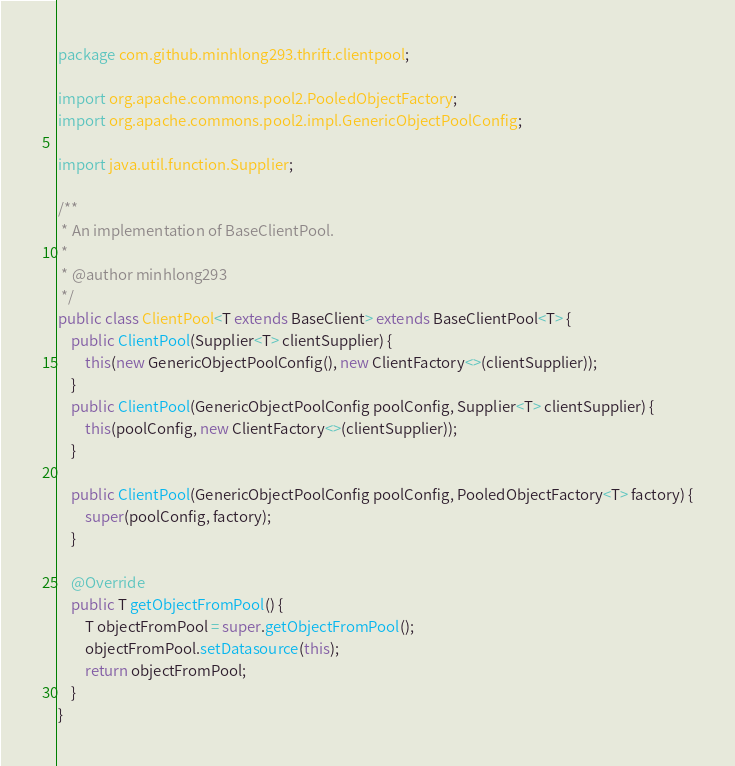<code> <loc_0><loc_0><loc_500><loc_500><_Java_>package com.github.minhlong293.thrift.clientpool;

import org.apache.commons.pool2.PooledObjectFactory;
import org.apache.commons.pool2.impl.GenericObjectPoolConfig;

import java.util.function.Supplier;

/**
 * An implementation of BaseClientPool.
 *
 * @author minhlong293
 */
public class ClientPool<T extends BaseClient> extends BaseClientPool<T> {
    public ClientPool(Supplier<T> clientSupplier) {
        this(new GenericObjectPoolConfig(), new ClientFactory<>(clientSupplier));
    }
    public ClientPool(GenericObjectPoolConfig poolConfig, Supplier<T> clientSupplier) {
        this(poolConfig, new ClientFactory<>(clientSupplier));
    }

    public ClientPool(GenericObjectPoolConfig poolConfig, PooledObjectFactory<T> factory) {
        super(poolConfig, factory);
    }

    @Override
    public T getObjectFromPool() {
        T objectFromPool = super.getObjectFromPool();
        objectFromPool.setDatasource(this);
        return objectFromPool;
    }
}
</code> 